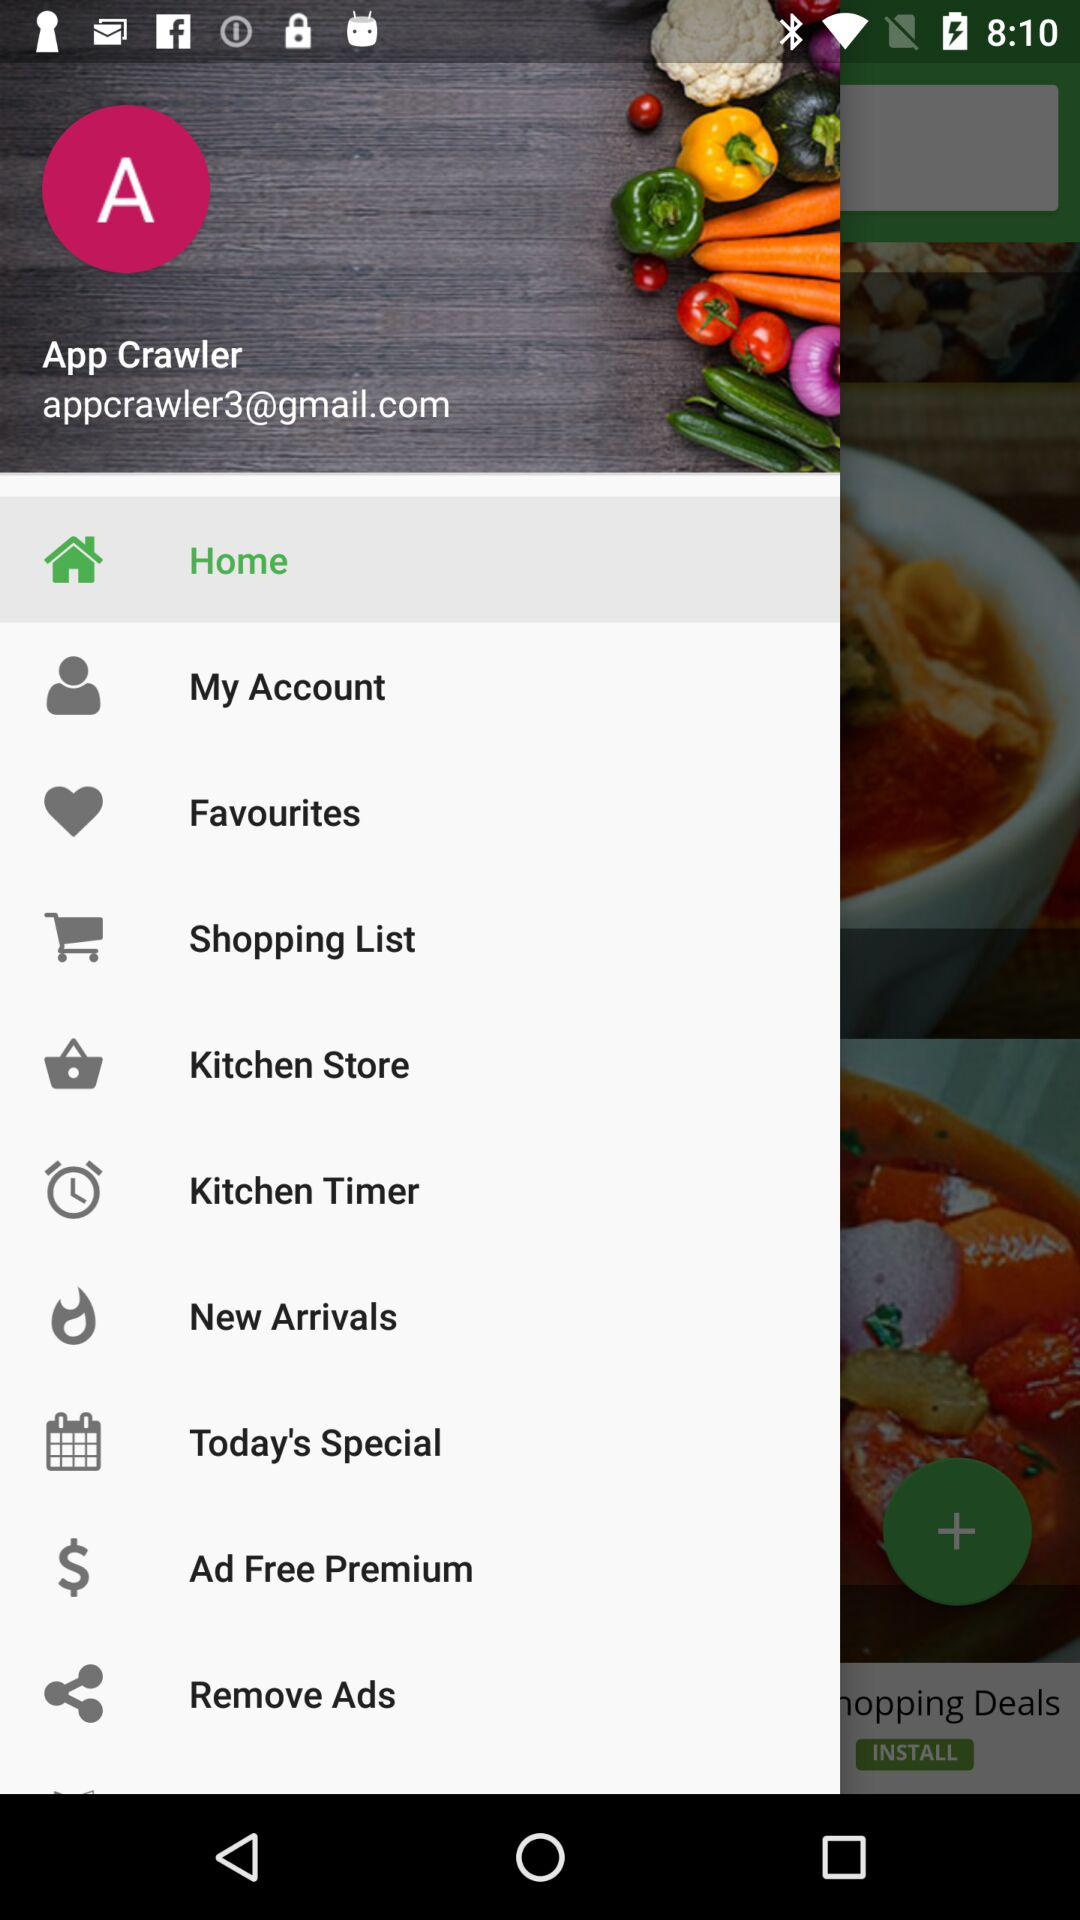What is the email address? The email address is appcrawler3@gmail.com. 